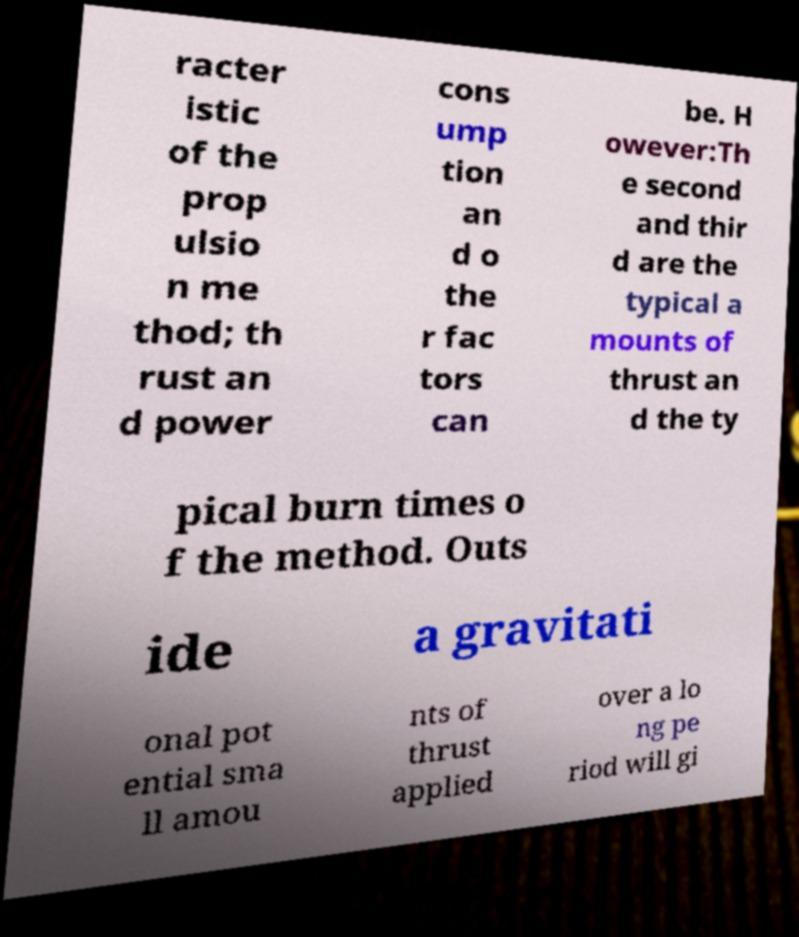Could you assist in decoding the text presented in this image and type it out clearly? racter istic of the prop ulsio n me thod; th rust an d power cons ump tion an d o the r fac tors can be. H owever:Th e second and thir d are the typical a mounts of thrust an d the ty pical burn times o f the method. Outs ide a gravitati onal pot ential sma ll amou nts of thrust applied over a lo ng pe riod will gi 